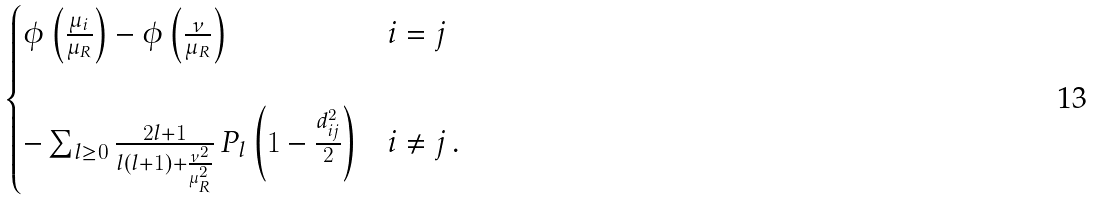Convert formula to latex. <formula><loc_0><loc_0><loc_500><loc_500>\begin{cases} \phi \left ( \frac { \mu _ { i } } { \mu _ { R } } \right ) - \phi \left ( \frac { \nu } { \mu _ { R } } \right ) & i = j \\ \\ - \sum _ { l \geq 0 } \frac { 2 l + 1 } { l ( l + 1 ) + \frac { \nu ^ { 2 } } { \mu _ { R } ^ { 2 } } } \, P _ { l } \left ( 1 - \frac { d _ { i j } ^ { 2 } } { 2 } \right ) & i \neq j \, . \end{cases}</formula> 